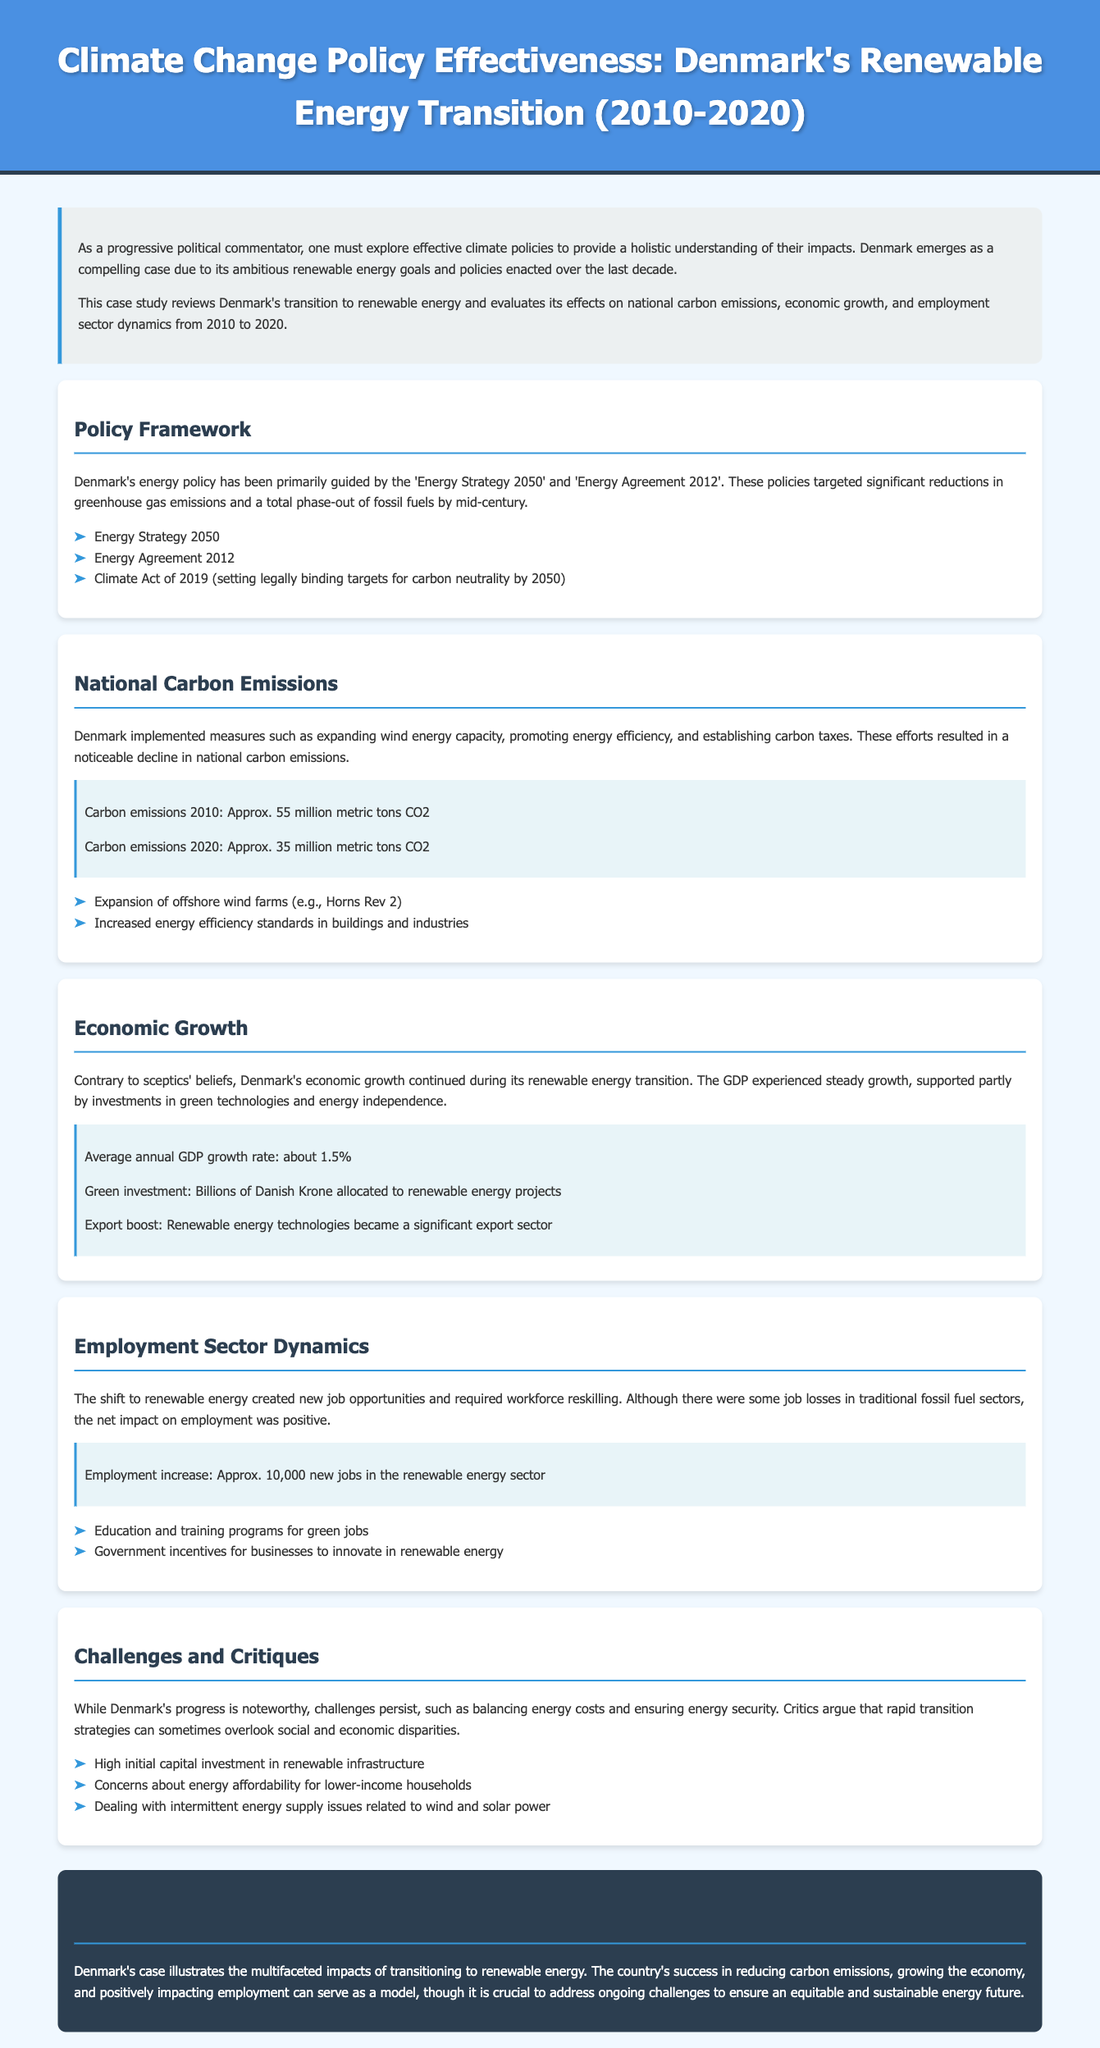What is Denmark's carbon emissions in 2010? The document states that Denmark's carbon emissions in 2010 were approximately 55 million metric tons CO2.
Answer: 55 million metric tons CO2 What is Denmark's carbon emissions in 2020? The document states that Denmark's carbon emissions in 2020 were approximately 35 million metric tons CO2.
Answer: 35 million metric tons CO2 What was the average annual GDP growth rate during Denmark's transition? The document mentions the average annual GDP growth rate was about 1.5%.
Answer: 1.5% How many new jobs were created in the renewable energy sector? The document states that there was an approximate increase of 10,000 new jobs in the renewable energy sector.
Answer: 10,000 What major energy policy set legally binding targets for carbon neutrality by 2050? The Climate Act of 2019 set legally binding targets for carbon neutrality by 2050.
Answer: Climate Act of 2019 What significant offshore wind farm was expanded in Denmark? The document mentions the expansion of Horns Rev 2 as a significant offshore wind farm.
Answer: Horns Rev 2 What were some challenges mentioned regarding Denmark's energy transition? The document lists high initial capital investment, energy affordability concerns, and intermittent energy supply issues as challenges.
Answer: High initial capital investment, energy affordability concerns, intermittent energy supply issues What did Denmark allocate billions of Danish Krone toward? The document states that billions of Danish Krone were allocated to renewable energy projects.
Answer: Renewable energy projects What strategy is cited for promoting energy efficiency in buildings and industries? The document refers to increased energy efficiency standards in buildings and industries as a strategy.
Answer: Increased energy efficiency standards 